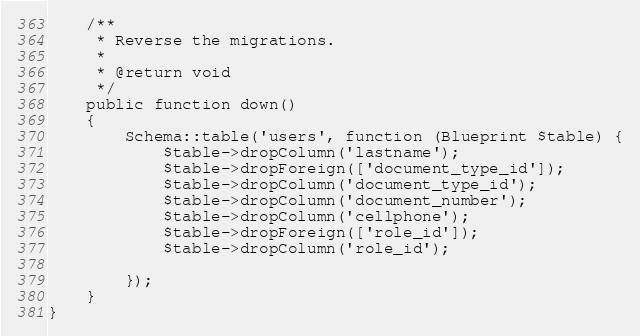<code> <loc_0><loc_0><loc_500><loc_500><_PHP_>    /**
     * Reverse the migrations.
     *
     * @return void
     */
    public function down()
    {
        Schema::table('users', function (Blueprint $table) {
            $table->dropColumn('lastname');
            $table->dropForeign(['document_type_id']);
            $table->dropColumn('document_type_id');
            $table->dropColumn('document_number');
            $table->dropColumn('cellphone');
            $table->dropForeign(['role_id']);
            $table->dropColumn('role_id');

        });
    }
}
</code> 